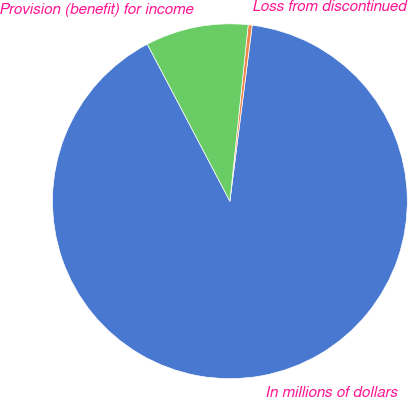Convert chart. <chart><loc_0><loc_0><loc_500><loc_500><pie_chart><fcel>In millions of dollars<fcel>Loss from discontinued<fcel>Provision (benefit) for income<nl><fcel>90.29%<fcel>0.36%<fcel>9.35%<nl></chart> 